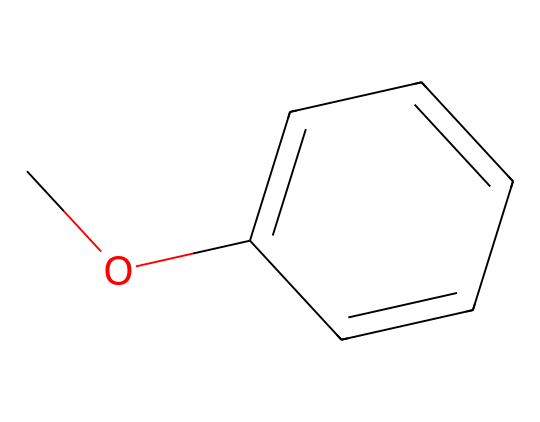How many carbon atoms are in methoxybenzene? By analyzing the SMILES representation, COc1ccccc1, we can count the carbon atoms. The "C" in "CO" represents one carbon atom, and the "c" represents the carbon atoms in the aromatic ring. There are six "c" in the ring plus one from the methoxy group, totaling seven carbon atoms.
Answer: seven What is the functional group present in methoxybenzene? In the structure represented by the SMILES, the "O" in "CO" indicates the presence of an oxygen atom bonded to a carbon atom, which classifies this compound as having a methoxy group (–OCH3). This functional group is characteristic of ethers.
Answer: ether How many hydrogen atoms are connected to the carbon atoms in methoxybenzene? From the carbon count, we know there are seven carbon atoms. The methoxy group contributes three hydrogens, while the five carbon atoms in the ring contribute five hydrogen atoms (since one hydrogen is replaced by the oxygen). Therefore, the total number of hydrogen atoms is 3 + 5 = 8.
Answer: eight What is the total number of atoms in methoxybenzene? To determine the total number of atoms, we count the individual elements from the SMILES. There are seven carbon (C) atoms, one oxygen (O) atom, and eight hydrogen (H) atoms. Adding these together gives 7 + 1 + 8 = 16.
Answer: sixteen Is methoxybenzene a polar or nonpolar molecule? The presence of the methoxy group introduces some polarity due to the electronegative oxygen atom. However, the overall structure is mainly nonpolar because of the large aromatic ring that dominates the molecule. Thus, while it has some polar character, it is largely considered nonpolar.
Answer: nonpolar How does the presence of the oxygen atom affect the reactivity of methoxybenzene? The oxygen in the methoxy group can act as an electron-donating group, making the aromatic ring more reactive towards electrophilic substitution reactions. It stabilizes the carbocation intermediate formed during such reactions, thereby increasing reactivity.
Answer: increases reactivity 